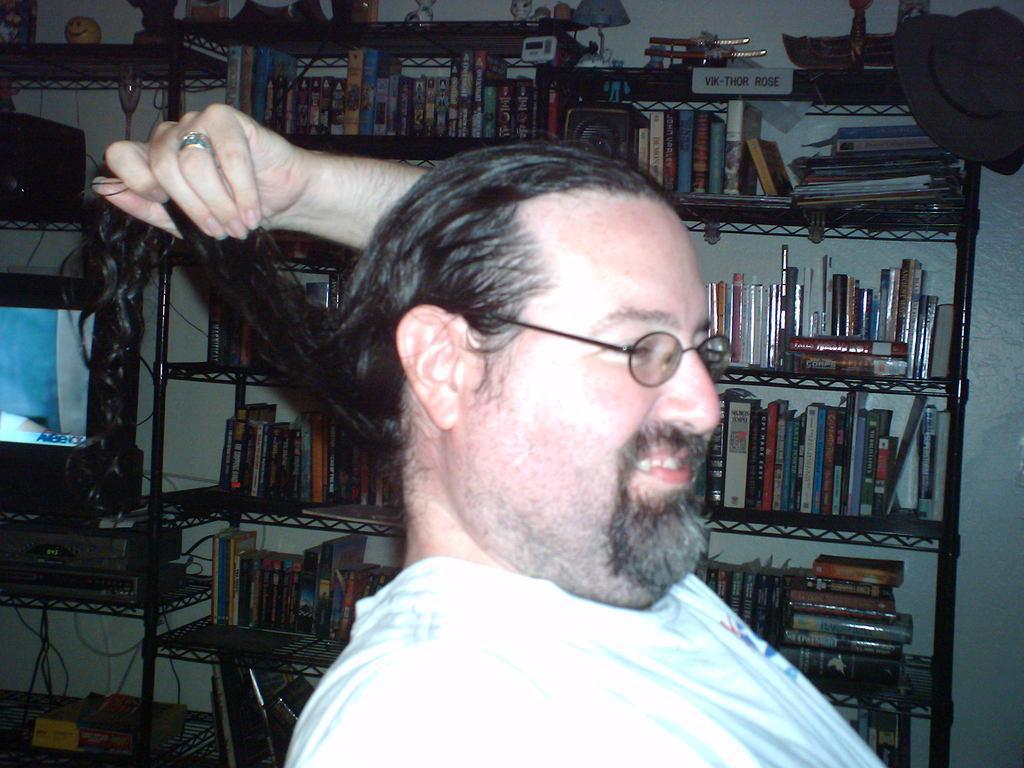Describe this image in one or two sentences. There is a man holding his hair in the foreground area of the image, there are books, it seems like a monitor and other items in the background. 